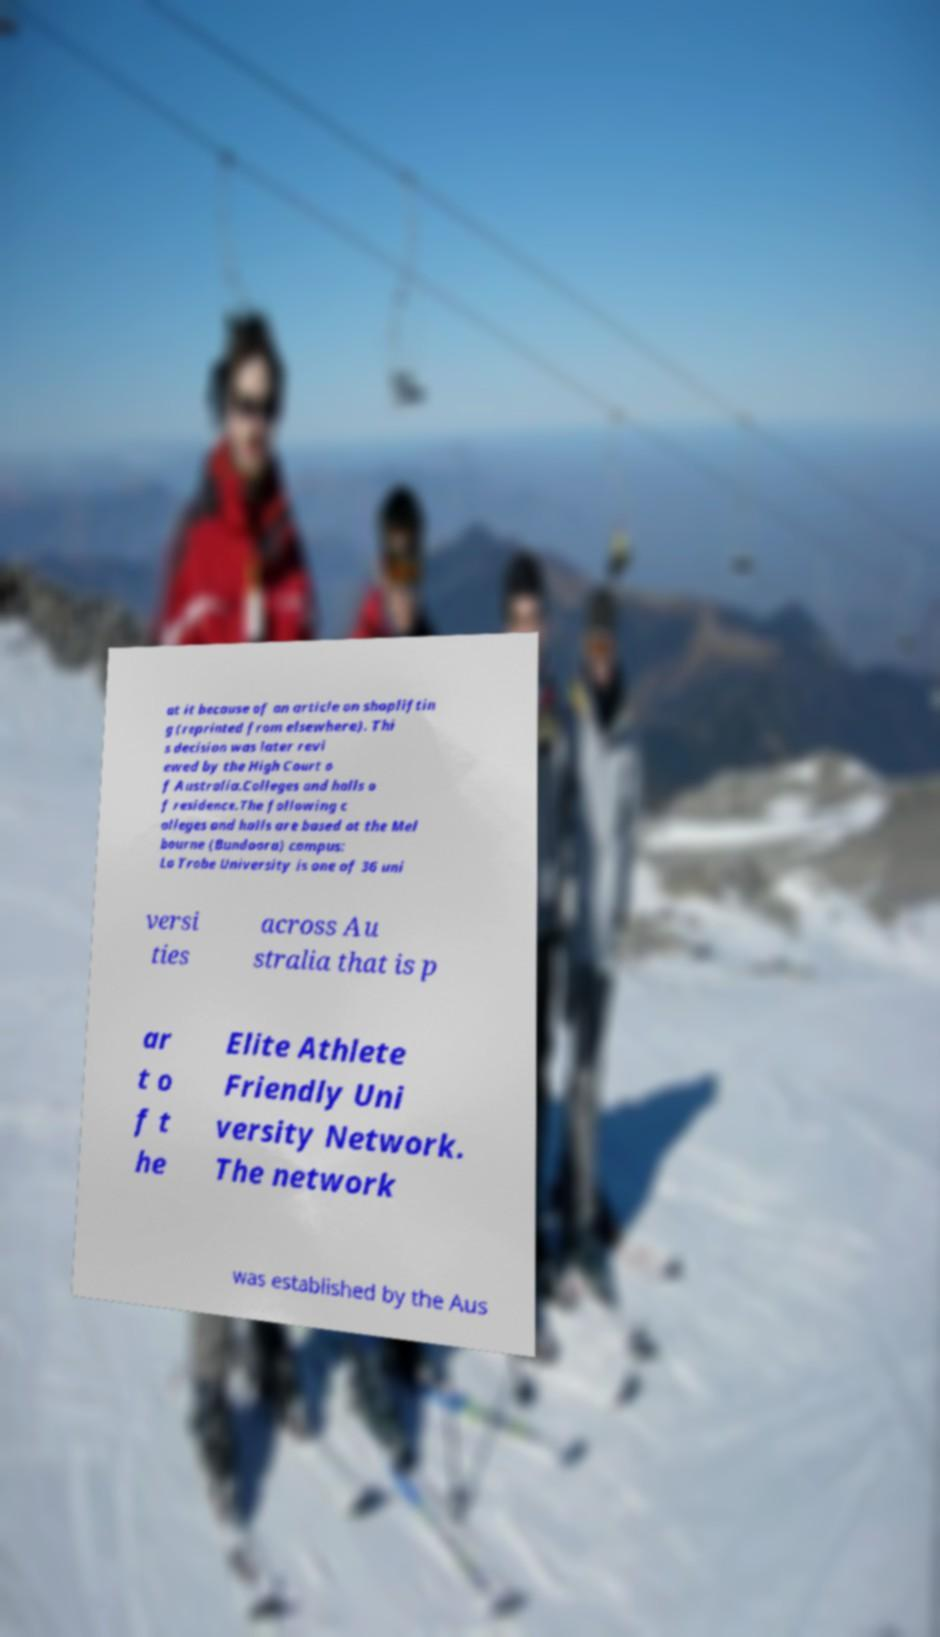For documentation purposes, I need the text within this image transcribed. Could you provide that? at it because of an article on shopliftin g (reprinted from elsewhere). Thi s decision was later revi ewed by the High Court o f Australia.Colleges and halls o f residence.The following c olleges and halls are based at the Mel bourne (Bundoora) campus: La Trobe University is one of 36 uni versi ties across Au stralia that is p ar t o f t he Elite Athlete Friendly Uni versity Network. The network was established by the Aus 